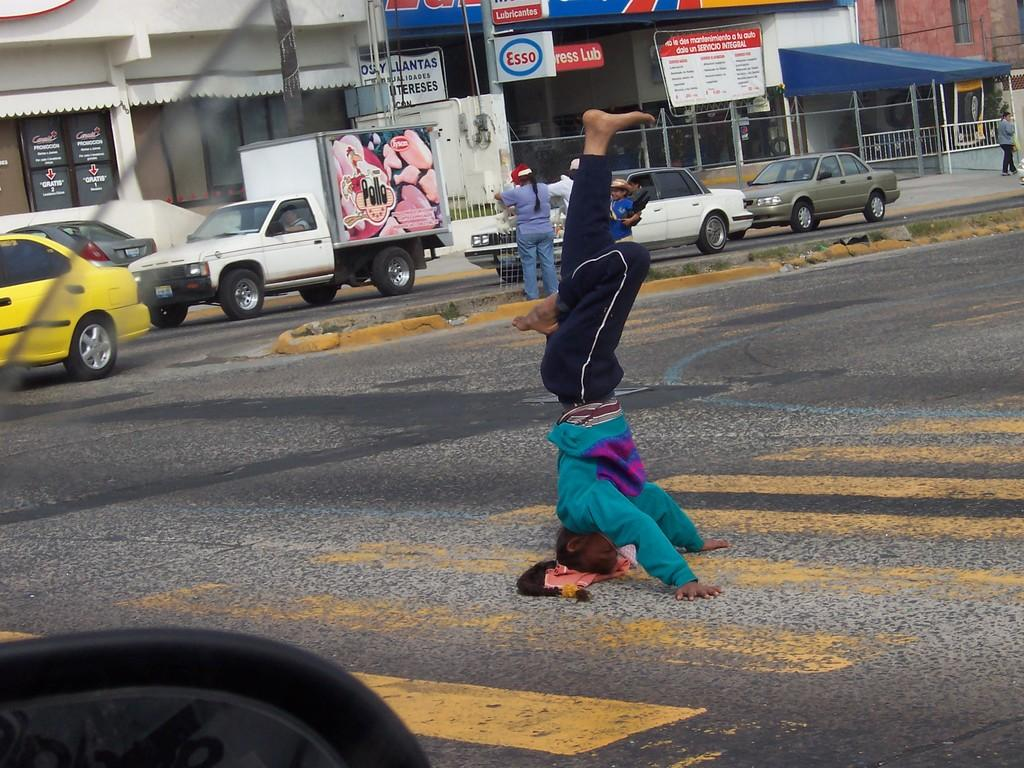<image>
Summarize the visual content of the image. An add for pollo is on the side of a truck. 